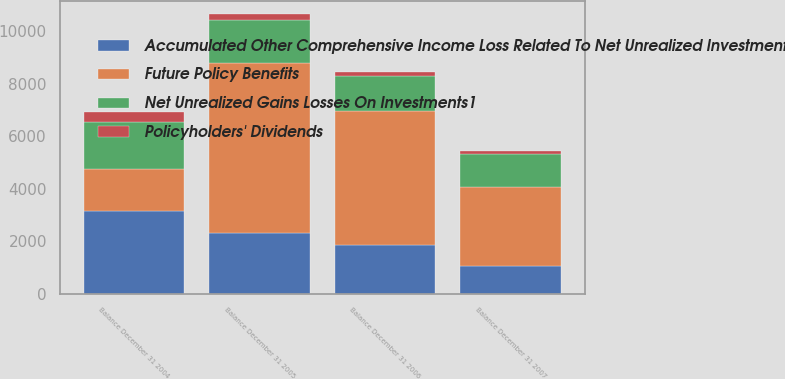<chart> <loc_0><loc_0><loc_500><loc_500><stacked_bar_chart><ecel><fcel>Balance December 31 2004<fcel>Balance December 31 2005<fcel>Balance December 31 2006<fcel>Balance December 31 2007<nl><fcel>Future Policy Benefits<fcel>1627<fcel>6499<fcel>5103<fcel>3025<nl><fcel>Policyholders' Dividends<fcel>372<fcel>220<fcel>173<fcel>118<nl><fcel>Net Unrealized Gains Losses On Investments1<fcel>1794<fcel>1627<fcel>1328<fcel>1242<nl><fcel>Accumulated Other Comprehensive Income Loss Related To Net Unrealized Investment Gains Losses<fcel>3141<fcel>2302<fcel>1866<fcel>1046<nl></chart> 